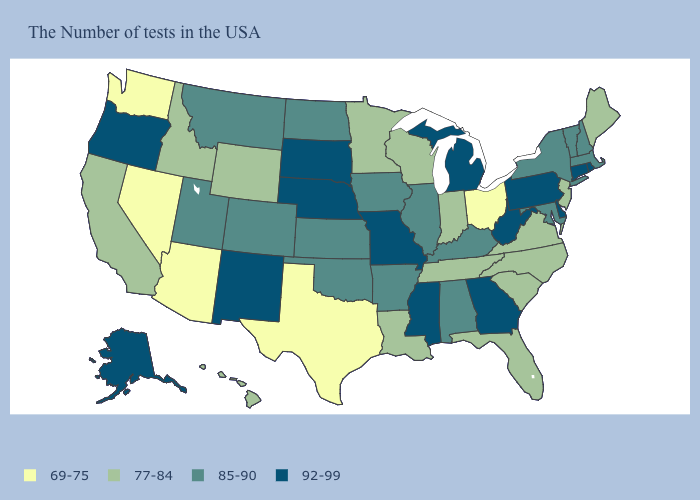What is the value of Missouri?
Short answer required. 92-99. Among the states that border New Hampshire , does Vermont have the highest value?
Keep it brief. Yes. How many symbols are there in the legend?
Concise answer only. 4. What is the highest value in the USA?
Keep it brief. 92-99. What is the lowest value in the USA?
Be succinct. 69-75. How many symbols are there in the legend?
Be succinct. 4. What is the value of South Carolina?
Short answer required. 77-84. Does New Jersey have the highest value in the Northeast?
Answer briefly. No. Which states have the lowest value in the USA?
Concise answer only. Ohio, Texas, Arizona, Nevada, Washington. Does the first symbol in the legend represent the smallest category?
Quick response, please. Yes. Among the states that border New Jersey , does Delaware have the highest value?
Short answer required. Yes. Does Indiana have a lower value than Arizona?
Answer briefly. No. What is the lowest value in the USA?
Be succinct. 69-75. Does the first symbol in the legend represent the smallest category?
Be succinct. Yes. Name the states that have a value in the range 92-99?
Concise answer only. Rhode Island, Connecticut, Delaware, Pennsylvania, West Virginia, Georgia, Michigan, Mississippi, Missouri, Nebraska, South Dakota, New Mexico, Oregon, Alaska. 